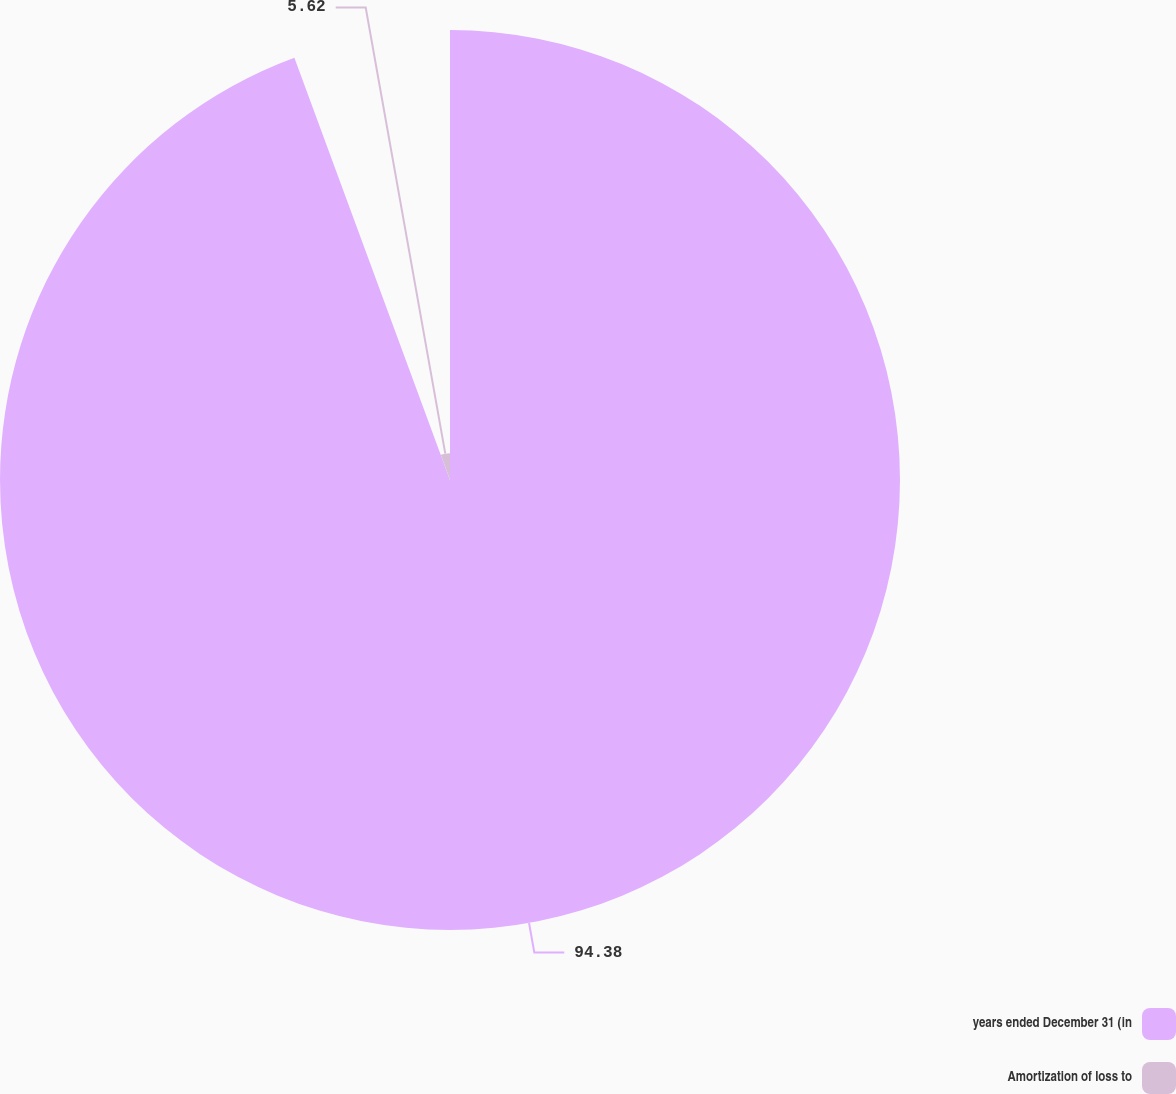<chart> <loc_0><loc_0><loc_500><loc_500><pie_chart><fcel>years ended December 31 (in<fcel>Amortization of loss to<nl><fcel>94.38%<fcel>5.62%<nl></chart> 